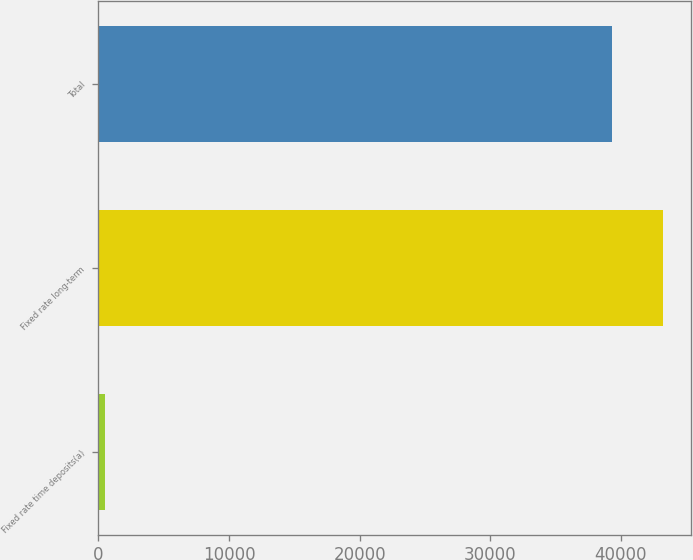<chart> <loc_0><loc_0><loc_500><loc_500><bar_chart><fcel>Fixed rate time deposits(a)<fcel>Fixed rate long-term<fcel>Total<nl><fcel>503<fcel>43228.9<fcel>39299<nl></chart> 